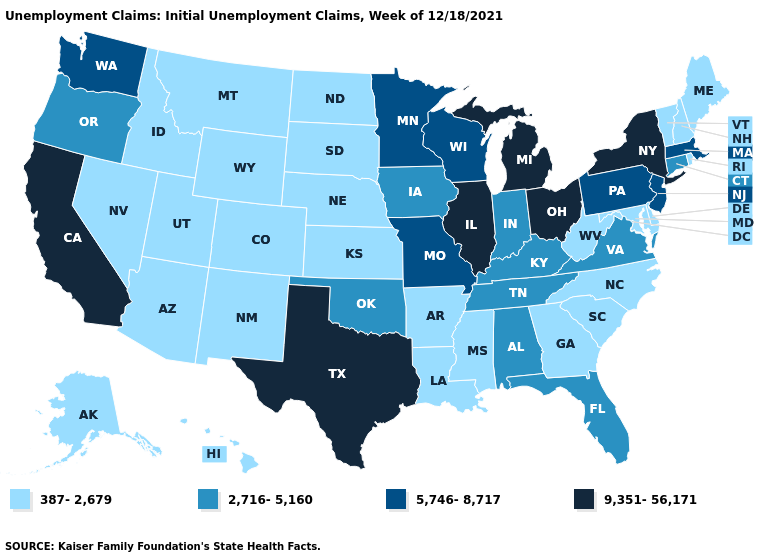Which states have the highest value in the USA?
Give a very brief answer. California, Illinois, Michigan, New York, Ohio, Texas. Does Hawaii have the lowest value in the USA?
Quick response, please. Yes. Which states hav the highest value in the West?
Answer briefly. California. Which states have the lowest value in the South?
Keep it brief. Arkansas, Delaware, Georgia, Louisiana, Maryland, Mississippi, North Carolina, South Carolina, West Virginia. What is the value of Nebraska?
Keep it brief. 387-2,679. Does the first symbol in the legend represent the smallest category?
Answer briefly. Yes. Does North Carolina have a higher value than South Dakota?
Answer briefly. No. What is the highest value in the MidWest ?
Give a very brief answer. 9,351-56,171. What is the lowest value in the USA?
Answer briefly. 387-2,679. What is the value of Pennsylvania?
Give a very brief answer. 5,746-8,717. Name the states that have a value in the range 9,351-56,171?
Concise answer only. California, Illinois, Michigan, New York, Ohio, Texas. Among the states that border Kentucky , which have the highest value?
Concise answer only. Illinois, Ohio. Which states have the lowest value in the USA?
Short answer required. Alaska, Arizona, Arkansas, Colorado, Delaware, Georgia, Hawaii, Idaho, Kansas, Louisiana, Maine, Maryland, Mississippi, Montana, Nebraska, Nevada, New Hampshire, New Mexico, North Carolina, North Dakota, Rhode Island, South Carolina, South Dakota, Utah, Vermont, West Virginia, Wyoming. What is the value of Montana?
Concise answer only. 387-2,679. Name the states that have a value in the range 2,716-5,160?
Keep it brief. Alabama, Connecticut, Florida, Indiana, Iowa, Kentucky, Oklahoma, Oregon, Tennessee, Virginia. 